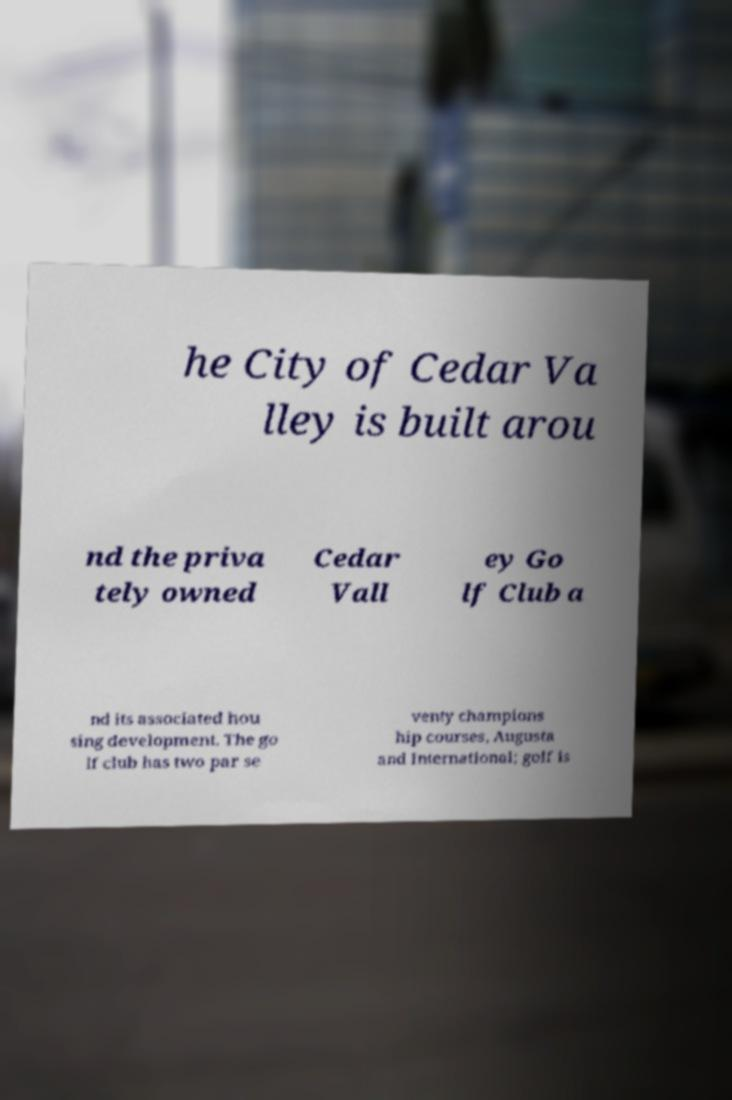What messages or text are displayed in this image? I need them in a readable, typed format. he City of Cedar Va lley is built arou nd the priva tely owned Cedar Vall ey Go lf Club a nd its associated hou sing development. The go lf club has two par se venty champions hip courses, Augusta and International; golf is 